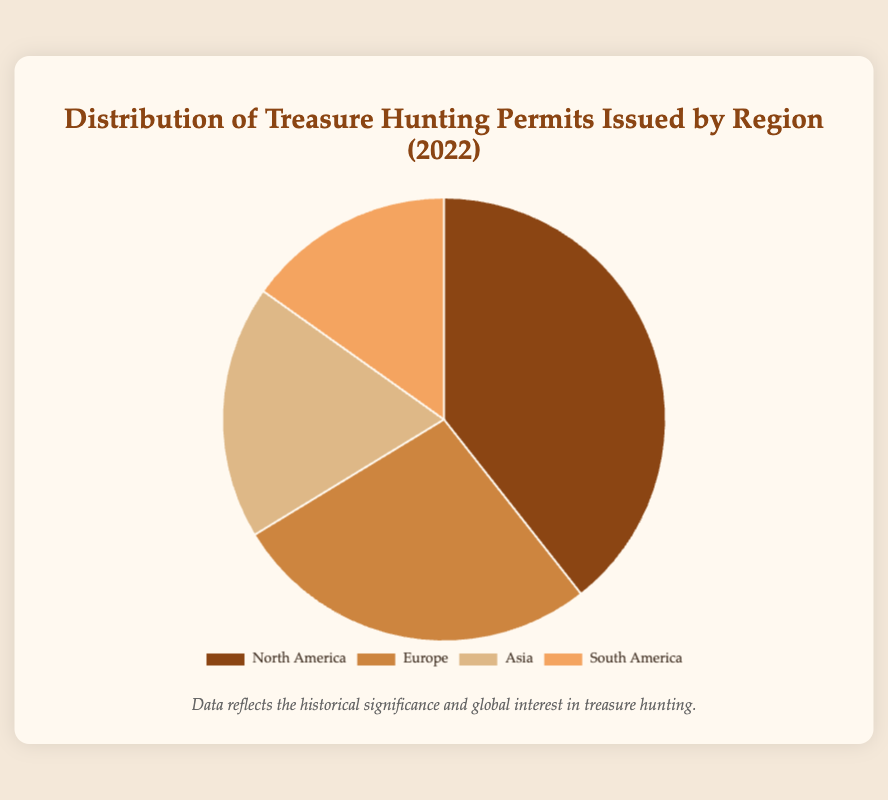What's the total number of treasure hunting permits issued in 2022? Sum the number of permits issued for each region: 457 (North America) + 312 (Europe) + 215 (Asia) + 176 (South America). This gives 1160.
Answer: 1160 Which region has the highest number of permits issued? Compare the numbers for all regions: North America (457), Europe (312), Asia (215), and South America (176). North America has the highest number.
Answer: North America What percentage of the permits were issued in Asia? Divide the number of permits issued in Asia by the total number of permits and multiply by 100: (215 / 1160) * 100. This gives approximately 18.53%.
Answer: 18.53% How does the number of permits issued in South America compare to Europe? Subtract the number of permits in South America (176) from the number in Europe (312). This gives 312 - 176 = 136. Europe issued 136 more permits than South America.
Answer: 136 What is the combined total of permits issued in the Americas (North and South)? Add the permits issued in North America (457) and South America (176): 457 + 176 = 633.
Answer: 633 Which regions combined issued more permits: North America and Europe, or Asia and South America? Add the permits for both combinations: North America + Europe = 457 + 312 = 769; Asia + South America = 215 + 176 = 391. North America and Europe issued more permits.
Answer: North America and Europe If a region is randomly selected, which region is it most likely to be? The likelihood is highest for the region with the most permits issued. North America has the highest number of permits (457).
Answer: North America What is the ratio of permits issued between Europe and Asia? Divide the number of permits in Europe (312) by the number in Asia (215): 312 / 215 ≈ 1.45.
Answer: 1.45 What fraction of the total permits were issued in South America? Divide the number of permits in South America by the total number of permits: 176 / 1160. This simplifies to approximately 0.1517, which is roughly 15/100.
Answer: 15/100 